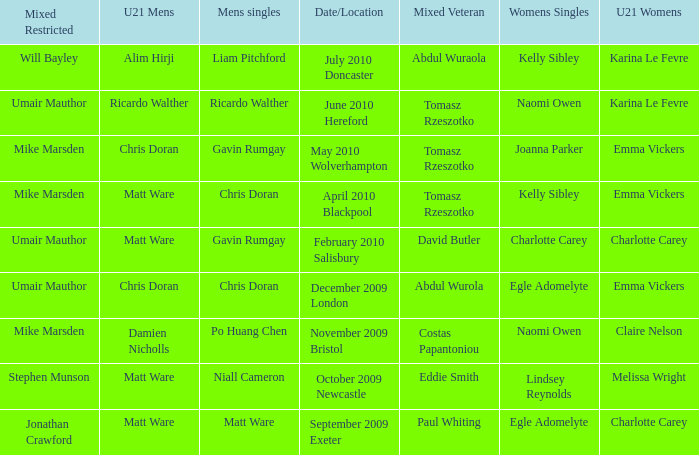When Paul Whiting won the mixed veteran, who won the mixed restricted? Jonathan Crawford. 